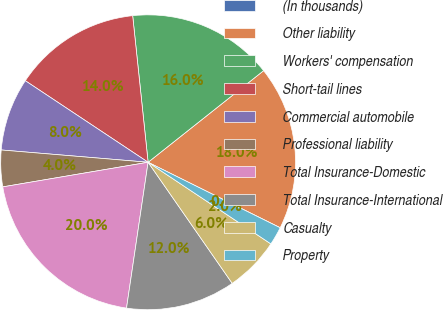<chart> <loc_0><loc_0><loc_500><loc_500><pie_chart><fcel>(In thousands)<fcel>Other liability<fcel>Workers' compensation<fcel>Short-tail lines<fcel>Commercial automobile<fcel>Professional liability<fcel>Total Insurance-Domestic<fcel>Total Insurance-International<fcel>Casualty<fcel>Property<nl><fcel>0.01%<fcel>17.99%<fcel>16.0%<fcel>14.0%<fcel>8.0%<fcel>4.0%<fcel>19.99%<fcel>12.0%<fcel>6.0%<fcel>2.01%<nl></chart> 